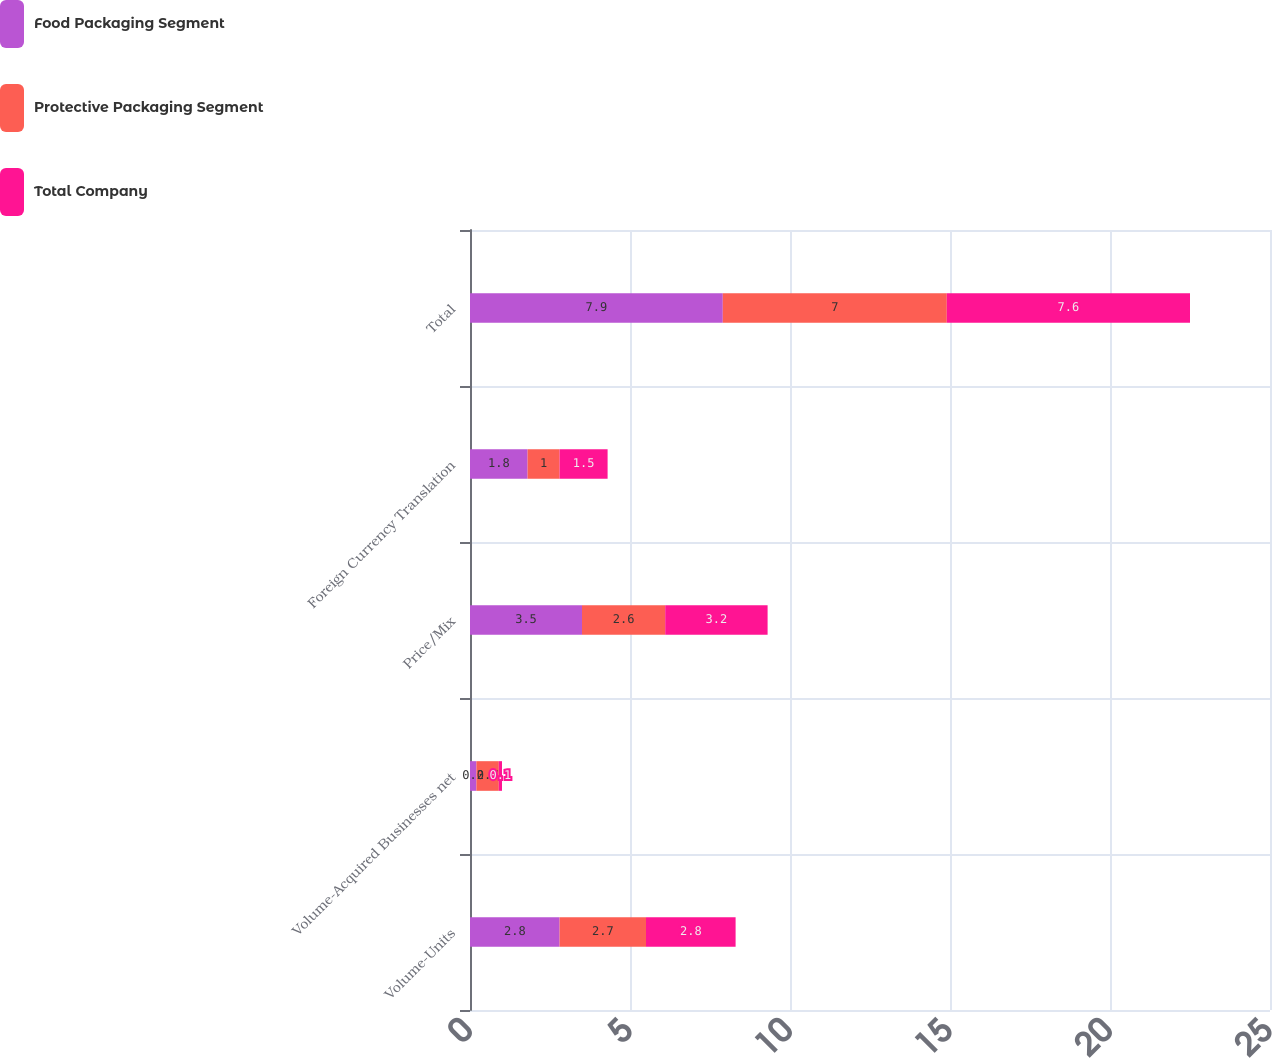Convert chart to OTSL. <chart><loc_0><loc_0><loc_500><loc_500><stacked_bar_chart><ecel><fcel>Volume-Units<fcel>Volume-Acquired Businesses net<fcel>Price/Mix<fcel>Foreign Currency Translation<fcel>Total<nl><fcel>Food Packaging Segment<fcel>2.8<fcel>0.2<fcel>3.5<fcel>1.8<fcel>7.9<nl><fcel>Protective Packaging Segment<fcel>2.7<fcel>0.7<fcel>2.6<fcel>1<fcel>7<nl><fcel>Total Company<fcel>2.8<fcel>0.1<fcel>3.2<fcel>1.5<fcel>7.6<nl></chart> 